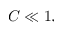Convert formula to latex. <formula><loc_0><loc_0><loc_500><loc_500>C \ll 1 ,</formula> 